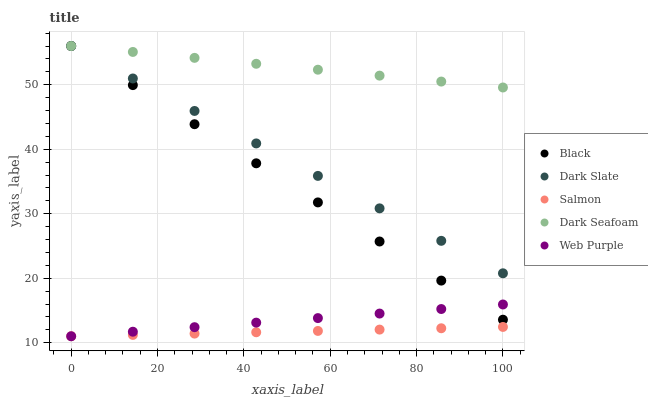Does Salmon have the minimum area under the curve?
Answer yes or no. Yes. Does Dark Seafoam have the maximum area under the curve?
Answer yes or no. Yes. Does Black have the minimum area under the curve?
Answer yes or no. No. Does Black have the maximum area under the curve?
Answer yes or no. No. Is Dark Seafoam the smoothest?
Answer yes or no. Yes. Is Black the roughest?
Answer yes or no. Yes. Is Black the smoothest?
Answer yes or no. No. Is Dark Seafoam the roughest?
Answer yes or no. No. Does Web Purple have the lowest value?
Answer yes or no. Yes. Does Black have the lowest value?
Answer yes or no. No. Does Black have the highest value?
Answer yes or no. Yes. Does Web Purple have the highest value?
Answer yes or no. No. Is Salmon less than Dark Seafoam?
Answer yes or no. Yes. Is Black greater than Salmon?
Answer yes or no. Yes. Does Black intersect Dark Slate?
Answer yes or no. Yes. Is Black less than Dark Slate?
Answer yes or no. No. Is Black greater than Dark Slate?
Answer yes or no. No. Does Salmon intersect Dark Seafoam?
Answer yes or no. No. 